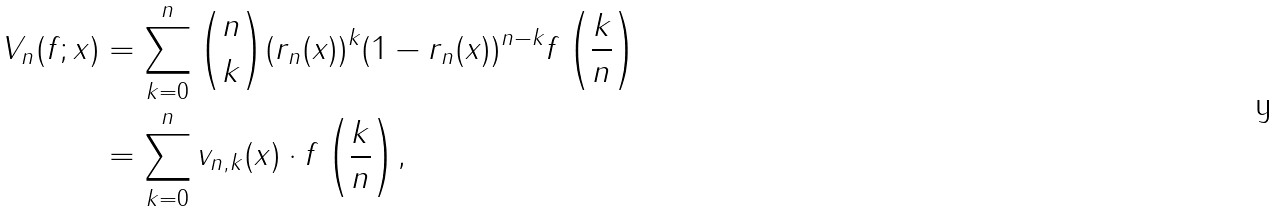<formula> <loc_0><loc_0><loc_500><loc_500>V _ { n } ( f ; x ) & = \sum ^ { n } _ { k = 0 } { \binom { n } { k } ( r _ { n } ( x ) ) ^ { k } ( 1 - r _ { n } ( x ) ) ^ { n - k } f \left ( \frac { k } { n } \right ) } \\ & = \sum ^ { n } _ { k = 0 } { v _ { n , k } ( x ) \cdot f \left ( \frac { k } { n } \right ) } ,</formula> 